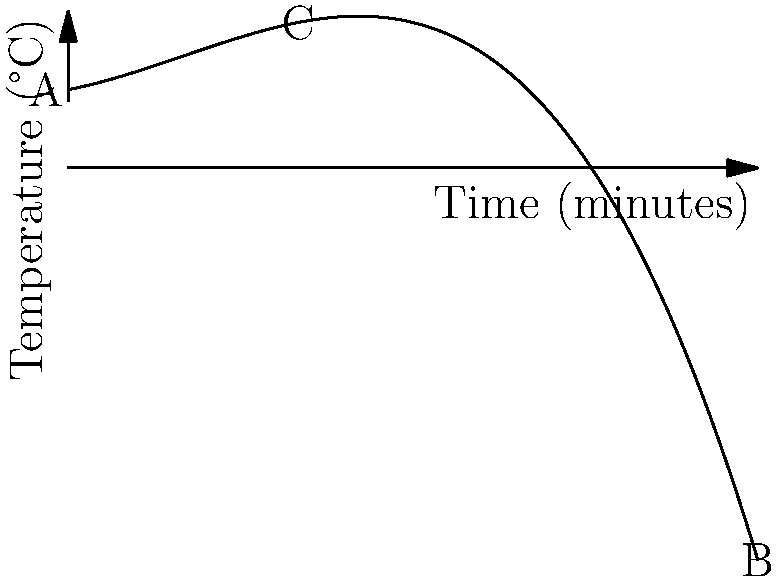The graph shows the temperature distribution in a pressure canner over time, represented by the polynomial function $f(x) = -0.005x^3 + 0.15x^2 + 2x + 70$, where $x$ is time in minutes and $f(x)$ is temperature in °C. At what time does the canner reach its maximum temperature, and what is that temperature? To find the maximum temperature and when it occurs:

1. Find the derivative of the function:
   $f'(x) = -0.015x^2 + 0.3x + 2$

2. Set the derivative to zero and solve for x:
   $-0.015x^2 + 0.3x + 2 = 0$
   
3. This is a quadratic equation. Use the quadratic formula:
   $x = \frac{-b \pm \sqrt{b^2 - 4ac}}{2a}$
   
   Where $a = -0.015$, $b = 0.3$, and $c = 2$

4. Solving:
   $x = \frac{-0.3 \pm \sqrt{0.3^2 - 4(-0.015)(2)}}{2(-0.015)}$
   $x \approx 30$ minutes or $x \approx 44.44$ minutes

5. The second derivative test shows that x = 30 is the maximum.

6. Calculate the maximum temperature:
   $f(30) = -0.005(30)^3 + 0.15(30)^2 + 2(30) + 70$
   $f(30) \approx 130.5°C$

Therefore, the canner reaches its maximum temperature of approximately 130.5°C after 30 minutes.
Answer: 30 minutes, 130.5°C 